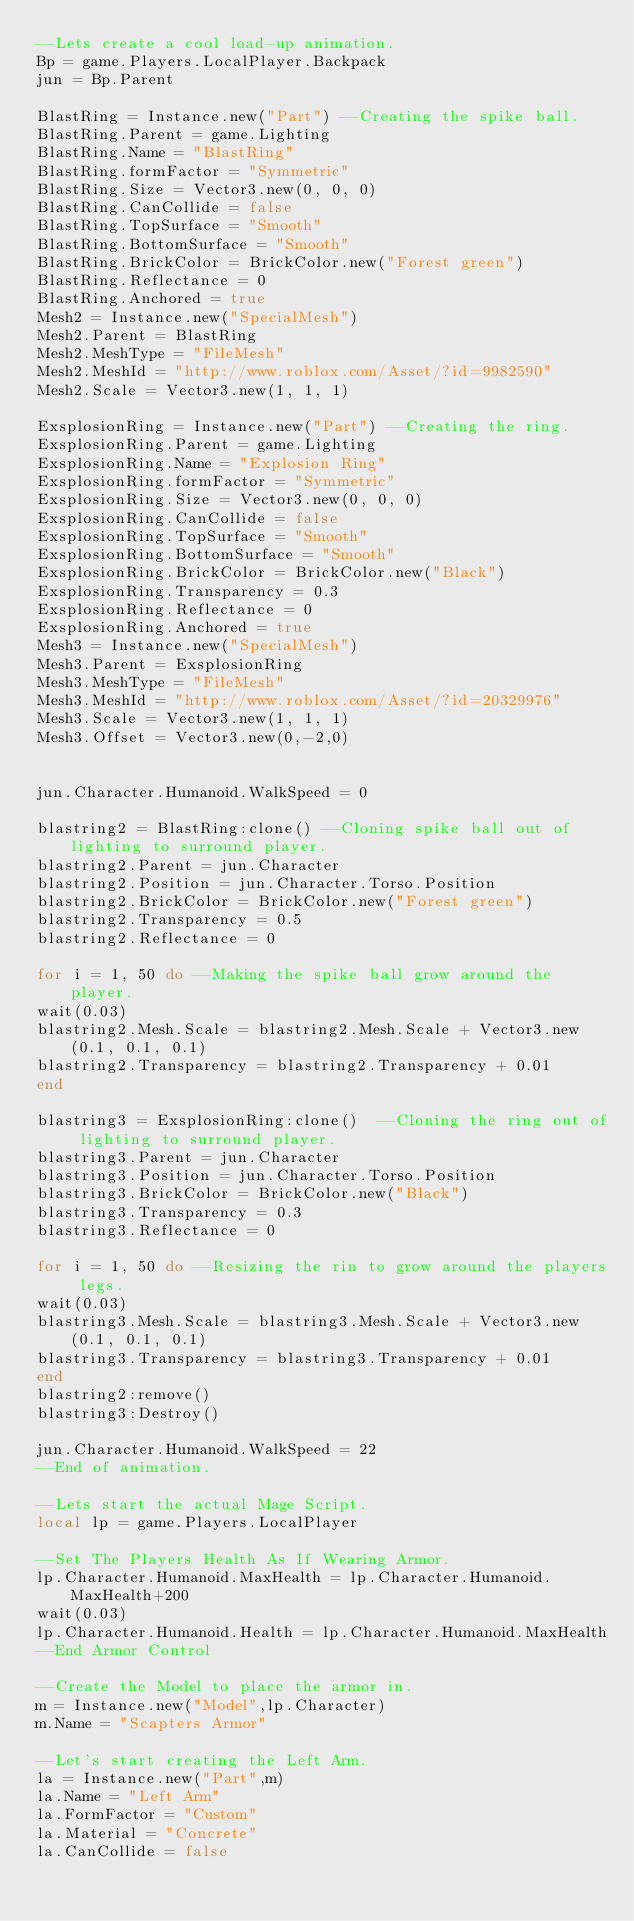Convert code to text. <code><loc_0><loc_0><loc_500><loc_500><_Lua_>--Lets create a cool load-up animation.
Bp = game.Players.LocalPlayer.Backpack
jun = Bp.Parent

BlastRing = Instance.new("Part") --Creating the spike ball.
BlastRing.Parent = game.Lighting 
BlastRing.Name = "BlastRing" 
BlastRing.formFactor = "Symmetric" 
BlastRing.Size = Vector3.new(0, 0, 0) 
BlastRing.CanCollide = false 
BlastRing.TopSurface = "Smooth" 
BlastRing.BottomSurface = "Smooth" 
BlastRing.BrickColor = BrickColor.new("Forest green") 
BlastRing.Reflectance = 0 
BlastRing.Anchored = true 
Mesh2 = Instance.new("SpecialMesh") 
Mesh2.Parent = BlastRing 
Mesh2.MeshType = "FileMesh" 
Mesh2.MeshId = "http://www.roblox.com/Asset/?id=9982590" 
Mesh2.Scale = Vector3.new(1, 1, 1)

ExsplosionRing = Instance.new("Part") --Creating the ring.
ExsplosionRing.Parent = game.Lighting 
ExsplosionRing.Name = "Explosion Ring" 
ExsplosionRing.formFactor = "Symmetric" 
ExsplosionRing.Size = Vector3.new(0, 0, 0) 
ExsplosionRing.CanCollide = false 
ExsplosionRing.TopSurface = "Smooth" 
ExsplosionRing.BottomSurface = "Smooth" 
ExsplosionRing.BrickColor = BrickColor.new("Black") 
ExsplosionRing.Transparency = 0.3
ExsplosionRing.Reflectance = 0 
ExsplosionRing.Anchored = true 
Mesh3 = Instance.new("SpecialMesh") 
Mesh3.Parent = ExsplosionRing 
Mesh3.MeshType = "FileMesh" 
Mesh3.MeshId = "http://www.roblox.com/Asset/?id=20329976" 
Mesh3.Scale = Vector3.new(1, 1, 1)
Mesh3.Offset = Vector3.new(0,-2,0)


jun.Character.Humanoid.WalkSpeed = 0

blastring2 = BlastRing:clone() --Cloning spike ball out of lighting to surround player.
blastring2.Parent = jun.Character 
blastring2.Position = jun.Character.Torso.Position 
blastring2.BrickColor = BrickColor.new("Forest green") 
blastring2.Transparency = 0.5
blastring2.Reflectance = 0 

for i = 1, 50 do --Making the spike ball grow around the player.
wait(0.03)
blastring2.Mesh.Scale = blastring2.Mesh.Scale + Vector3.new(0.1, 0.1, 0.1)
blastring2.Transparency = blastring2.Transparency + 0.01
end

blastring3 = ExsplosionRing:clone()  --Cloning the ring out of lighting to surround player.
blastring3.Parent = jun.Character 
blastring3.Position = jun.Character.Torso.Position 
blastring3.BrickColor = BrickColor.new("Black") 
blastring3.Transparency = 0.3
blastring3.Reflectance = 0

for i = 1, 50 do --Resizing the rin to grow around the players legs.
wait(0.03)
blastring3.Mesh.Scale = blastring3.Mesh.Scale + Vector3.new(0.1, 0.1, 0.1)
blastring3.Transparency = blastring3.Transparency + 0.01
end
blastring2:remove()
blastring3:Destroy()

jun.Character.Humanoid.WalkSpeed = 22
--End of animation.

--Lets start the actual Mage Script.
local lp = game.Players.LocalPlayer

--Set The Players Health As If Wearing Armor.
lp.Character.Humanoid.MaxHealth = lp.Character.Humanoid.MaxHealth+200
wait(0.03)
lp.Character.Humanoid.Health = lp.Character.Humanoid.MaxHealth
--End Armor Control

--Create the Model to place the armor in.
m = Instance.new("Model",lp.Character)
m.Name = "Scapters Armor"

--Let's start creating the Left Arm.
la = Instance.new("Part",m)
la.Name = "Left Arm"
la.FormFactor = "Custom"
la.Material = "Concrete"
la.CanCollide = false</code> 